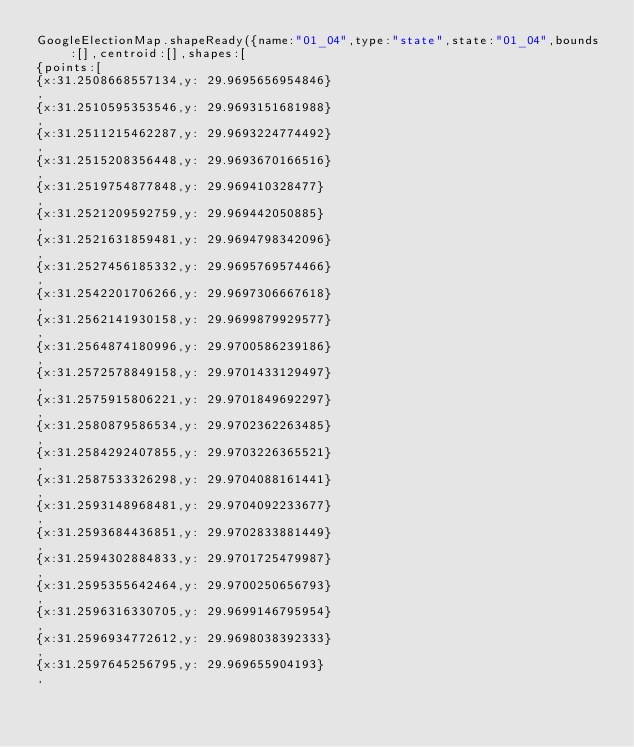Convert code to text. <code><loc_0><loc_0><loc_500><loc_500><_JavaScript_>GoogleElectionMap.shapeReady({name:"01_04",type:"state",state:"01_04",bounds:[],centroid:[],shapes:[
{points:[
{x:31.2508668557134,y: 29.9695656954846}
,
{x:31.2510595353546,y: 29.9693151681988}
,
{x:31.2511215462287,y: 29.9693224774492}
,
{x:31.2515208356448,y: 29.9693670166516}
,
{x:31.2519754877848,y: 29.969410328477}
,
{x:31.2521209592759,y: 29.969442050885}
,
{x:31.2521631859481,y: 29.9694798342096}
,
{x:31.2527456185332,y: 29.9695769574466}
,
{x:31.2542201706266,y: 29.9697306667618}
,
{x:31.2562141930158,y: 29.9699879929577}
,
{x:31.2564874180996,y: 29.9700586239186}
,
{x:31.2572578849158,y: 29.9701433129497}
,
{x:31.2575915806221,y: 29.9701849692297}
,
{x:31.2580879586534,y: 29.9702362263485}
,
{x:31.2584292407855,y: 29.9703226365521}
,
{x:31.2587533326298,y: 29.9704088161441}
,
{x:31.2593148968481,y: 29.9704092233677}
,
{x:31.2593684436851,y: 29.9702833881449}
,
{x:31.2594302884833,y: 29.9701725479987}
,
{x:31.2595355642464,y: 29.9700250656793}
,
{x:31.2596316330705,y: 29.9699146795954}
,
{x:31.2596934772612,y: 29.9698038392333}
,
{x:31.2597645256795,y: 29.969655904193}
,</code> 